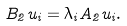<formula> <loc_0><loc_0><loc_500><loc_500>B _ { 2 } u _ { i } = \lambda _ { i } A _ { 2 } u _ { i } .</formula> 